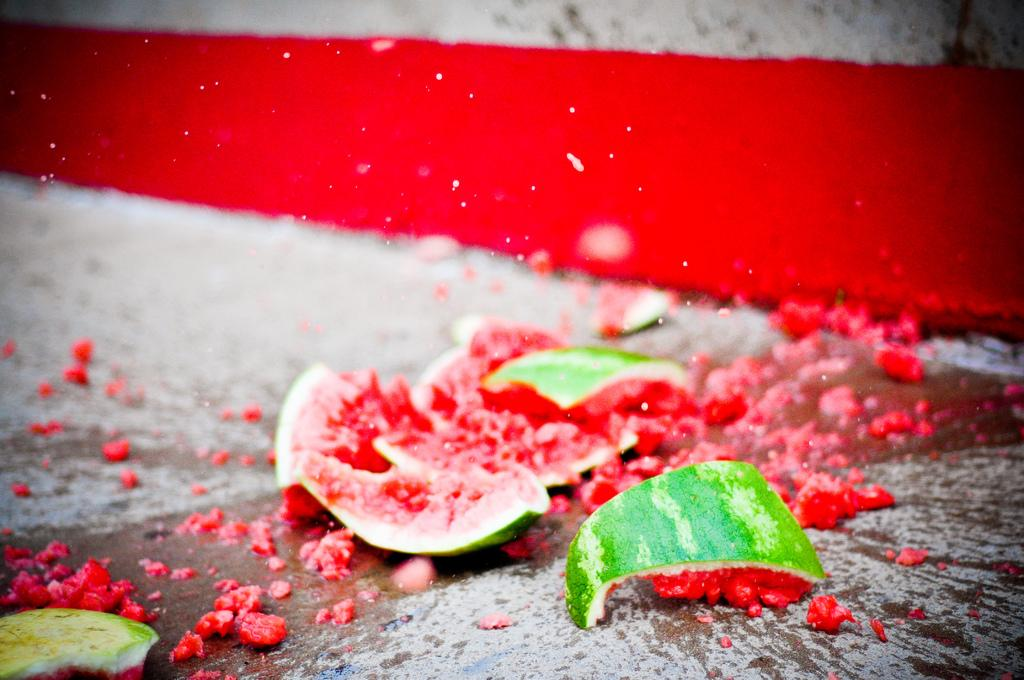What is the main subject of the image? The main subject of the image is a smashed watermelon. Where is the watermelon located in the image? The watermelon is on a surface in the image. How many items can be found in the watermelon's pocket in the image? There is no pocket present on the watermelon in the image. 